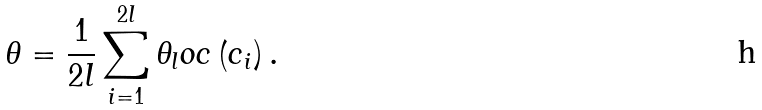<formula> <loc_0><loc_0><loc_500><loc_500>\theta = \frac { 1 } { 2 l } \sum _ { i = 1 } ^ { 2 l } \theta _ { l } o c \left ( c _ { i } \right ) .</formula> 